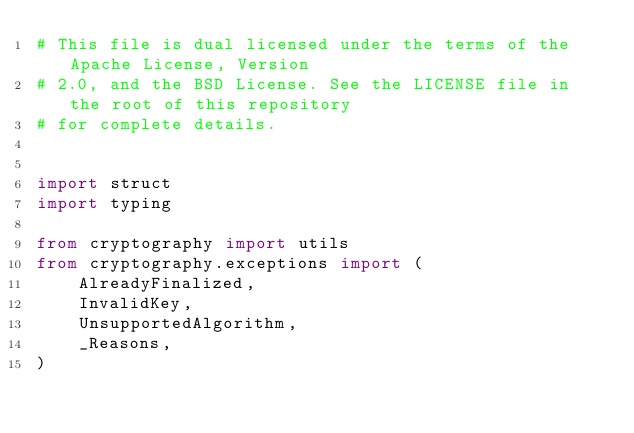Convert code to text. <code><loc_0><loc_0><loc_500><loc_500><_Python_># This file is dual licensed under the terms of the Apache License, Version
# 2.0, and the BSD License. See the LICENSE file in the root of this repository
# for complete details.


import struct
import typing

from cryptography import utils
from cryptography.exceptions import (
    AlreadyFinalized,
    InvalidKey,
    UnsupportedAlgorithm,
    _Reasons,
)</code> 